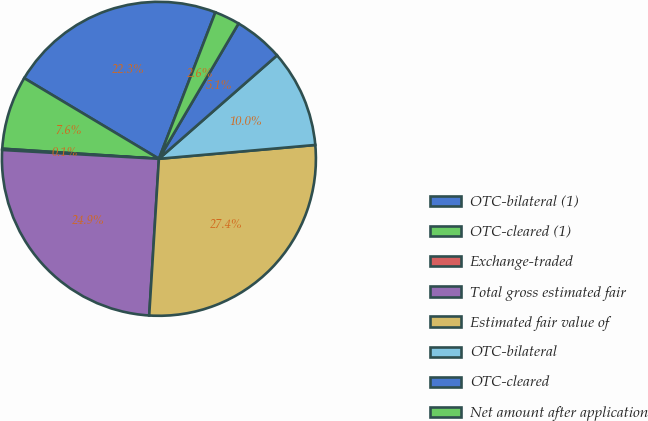Convert chart. <chart><loc_0><loc_0><loc_500><loc_500><pie_chart><fcel>OTC-bilateral (1)<fcel>OTC-cleared (1)<fcel>Exchange-traded<fcel>Total gross estimated fair<fcel>Estimated fair value of<fcel>OTC-bilateral<fcel>OTC-cleared<fcel>Net amount after application<nl><fcel>22.27%<fcel>7.56%<fcel>0.13%<fcel>24.91%<fcel>27.39%<fcel>10.04%<fcel>5.09%<fcel>2.61%<nl></chart> 